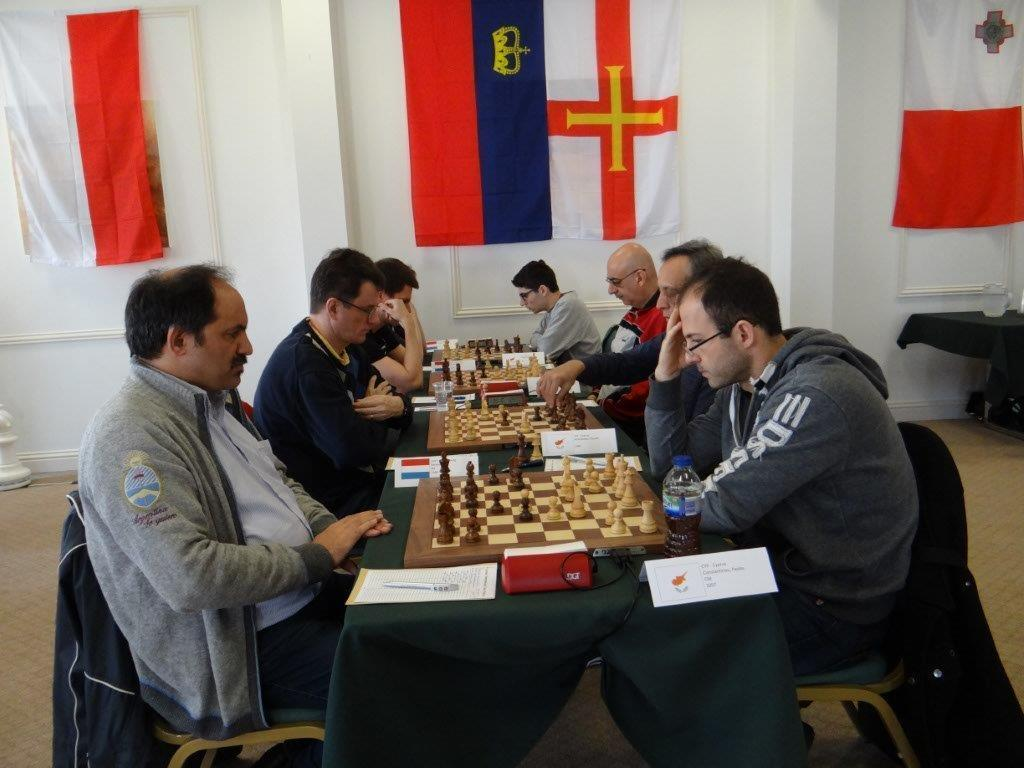What activity are the group of persons engaged in? The group of persons are playing chess. How are the persons interacting with each other during the game? The persons are playing against their opponents. What can be seen on the white wall in the background? There are flags on the white wall in the background. Can you tell me how many worms are crawling on the chessboard in the image? There are no worms present in the image; the focus is on the persons playing chess. What type of bone is visible on the chessboard in the image? There is no bone visible on the chessboard in the image. 